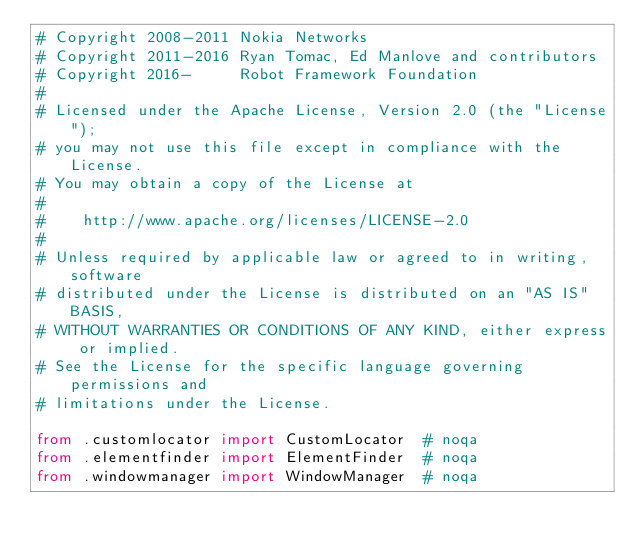<code> <loc_0><loc_0><loc_500><loc_500><_Python_># Copyright 2008-2011 Nokia Networks
# Copyright 2011-2016 Ryan Tomac, Ed Manlove and contributors
# Copyright 2016-     Robot Framework Foundation
#
# Licensed under the Apache License, Version 2.0 (the "License");
# you may not use this file except in compliance with the License.
# You may obtain a copy of the License at
#
#    http://www.apache.org/licenses/LICENSE-2.0
#
# Unless required by applicable law or agreed to in writing, software
# distributed under the License is distributed on an "AS IS" BASIS,
# WITHOUT WARRANTIES OR CONDITIONS OF ANY KIND, either express or implied.
# See the License for the specific language governing permissions and
# limitations under the License.

from .customlocator import CustomLocator  # noqa
from .elementfinder import ElementFinder  # noqa
from .windowmanager import WindowManager  # noqa
</code> 